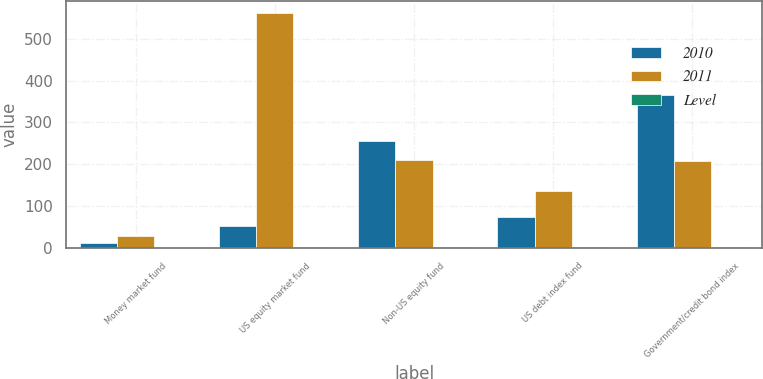Convert chart. <chart><loc_0><loc_0><loc_500><loc_500><stacked_bar_chart><ecel><fcel>Money market fund<fcel>US equity market fund<fcel>Non-US equity fund<fcel>US debt index fund<fcel>Government/credit bond index<nl><fcel>2010<fcel>12<fcel>51.35<fcel>256.1<fcel>75<fcel>366.2<nl><fcel>2011<fcel>27.7<fcel>561.9<fcel>210<fcel>135<fcel>208.1<nl><fcel>Level<fcel>1<fcel>2<fcel>2<fcel>2<fcel>2<nl></chart> 